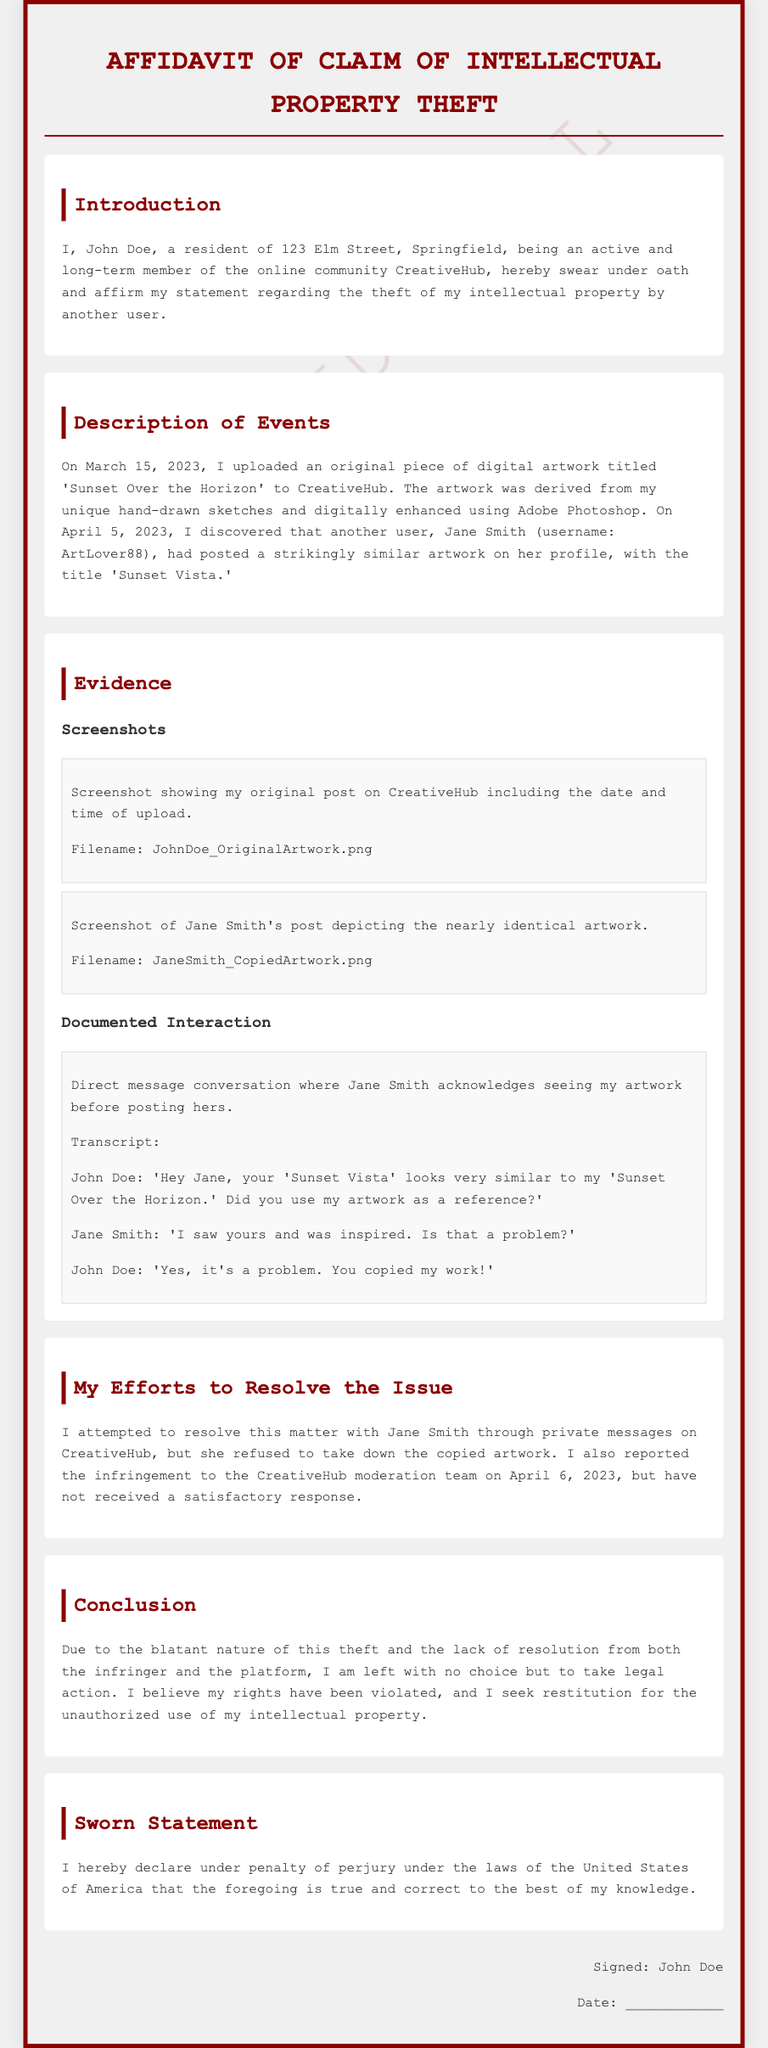What is the name of the complainant? The complainant, who swears the affidavit, is identified as John Doe.
Answer: John Doe What is the title of the original artwork? The original artwork uploaded by John Doe is titled 'Sunset Over the Horizon.'
Answer: Sunset Over the Horizon What date did John Doe upload his artwork? The affidavit states that John Doe uploaded his artwork on March 15, 2023.
Answer: March 15, 2023 What is the username of the alleged infringer? The username of the other user who allegedly copied John Doe's work is ArtLover88.
Answer: ArtLover88 What did Jane Smith say in response to John Doe's initial inquiry? Jane Smith acknowledged seeing John Doe's artwork and stated she was inspired by it.
Answer: I saw yours and was inspired Why did John Doe feel the need to take legal action? John Doe felt the need to take legal action due to the lack of resolution from both Jane Smith and the CreativeHub moderation team.
Answer: Lack of resolution What was the response from the CreativeHub moderation team? The affidavit indicates that John Doe did not receive a satisfactory response from the moderation team.
Answer: Unsatisfactory response What type of document is this? The content presented is classified as an affidavit regarding intellectual property theft.
Answer: Affidavit What evidence is included in this affidavit? The affidavit includes screenshots of artwork and a documented interaction between John Doe and Jane Smith.
Answer: Screenshots and documented interaction 